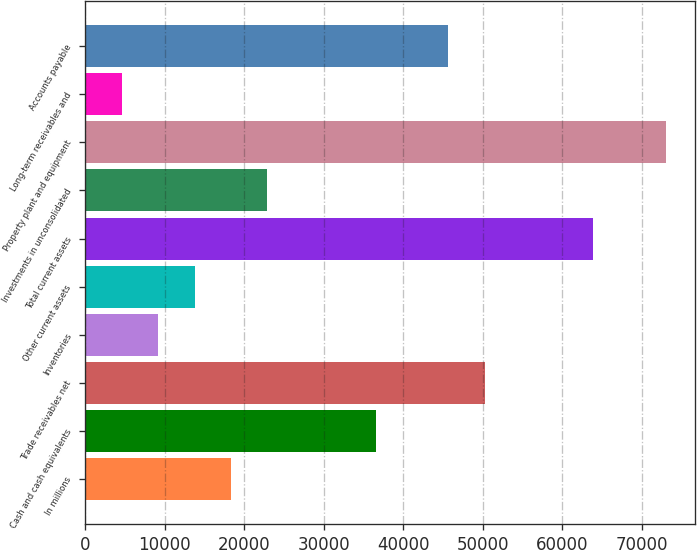Convert chart to OTSL. <chart><loc_0><loc_0><loc_500><loc_500><bar_chart><fcel>In millions<fcel>Cash and cash equivalents<fcel>Trade receivables net<fcel>Inventories<fcel>Other current assets<fcel>Total current assets<fcel>Investments in unconsolidated<fcel>Property plant and equipment<fcel>Long-term receivables and<fcel>Accounts payable<nl><fcel>18339.6<fcel>36569.2<fcel>50241.4<fcel>9224.8<fcel>13782.2<fcel>63913.6<fcel>22897<fcel>73028.4<fcel>4667.4<fcel>45684<nl></chart> 